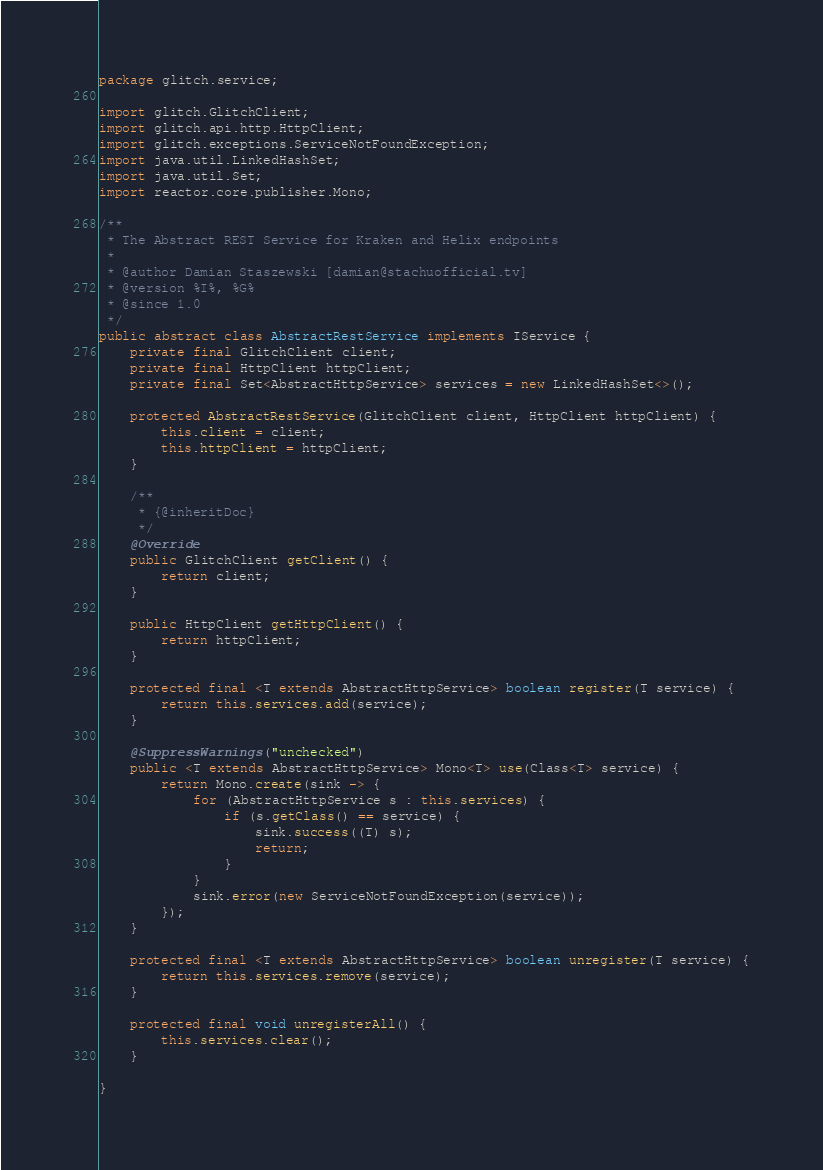<code> <loc_0><loc_0><loc_500><loc_500><_Java_>package glitch.service;

import glitch.GlitchClient;
import glitch.api.http.HttpClient;
import glitch.exceptions.ServiceNotFoundException;
import java.util.LinkedHashSet;
import java.util.Set;
import reactor.core.publisher.Mono;

/**
 * The Abstract REST Service for Kraken and Helix endpoints
 *
 * @author Damian Staszewski [damian@stachuofficial.tv]
 * @version %I%, %G%
 * @since 1.0
 */
public abstract class AbstractRestService implements IService {
    private final GlitchClient client;
    private final HttpClient httpClient;
    private final Set<AbstractHttpService> services = new LinkedHashSet<>();

    protected AbstractRestService(GlitchClient client, HttpClient httpClient) {
        this.client = client;
        this.httpClient = httpClient;
    }

    /**
     * {@inheritDoc}
     */
    @Override
    public GlitchClient getClient() {
        return client;
    }

    public HttpClient getHttpClient() {
        return httpClient;
    }

    protected final <T extends AbstractHttpService> boolean register(T service) {
        return this.services.add(service);
    }

    @SuppressWarnings("unchecked")
    public <T extends AbstractHttpService> Mono<T> use(Class<T> service) {
        return Mono.create(sink -> {
            for (AbstractHttpService s : this.services) {
                if (s.getClass() == service) {
                    sink.success((T) s);
                    return;
                }
            }
            sink.error(new ServiceNotFoundException(service));
        });
    }

    protected final <T extends AbstractHttpService> boolean unregister(T service) {
        return this.services.remove(service);
    }

    protected final void unregisterAll() {
        this.services.clear();
    }

}
</code> 